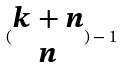Convert formula to latex. <formula><loc_0><loc_0><loc_500><loc_500>( \begin{matrix} k + n \\ n \end{matrix} ) - 1</formula> 